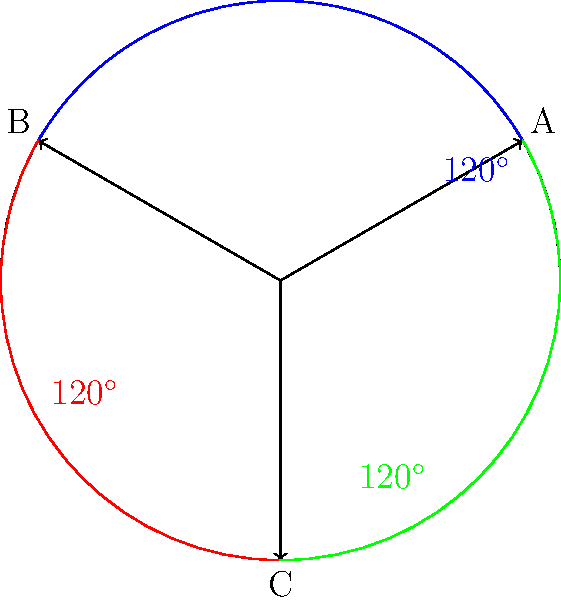In our latest UFO tracking operation, we've plotted three distinct sightings (A, B, and C) on a circular radar display. The angles between these sightings form an interesting pattern. If the angle between A and B is $120^\circ$, and the angle between B and C is also $120^\circ$, what is the angle between C and A? Let's approach this step-by-step:

1) First, recall that in a circle, the sum of all angles around the center point is $360^\circ$.

2) We're given that:
   - The angle between A and B is $120^\circ$
   - The angle between B and C is $120^\circ$

3) Let's call the angle between C and A as $x^\circ$.

4) Since these three angles form a complete circle, we can set up an equation:

   $120^\circ + 120^\circ + x^\circ = 360^\circ$

5) Simplifying:
   $240^\circ + x^\circ = 360^\circ$

6) Subtracting $240^\circ$ from both sides:
   $x^\circ = 360^\circ - 240^\circ = 120^\circ$

7) Therefore, the angle between C and A is also $120^\circ$.

This creates a symmetrical pattern where all three angles are equal, dividing the circle into three equal parts.
Answer: $120^\circ$ 